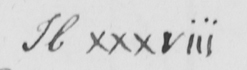What does this handwritten line say? H xxxviii 